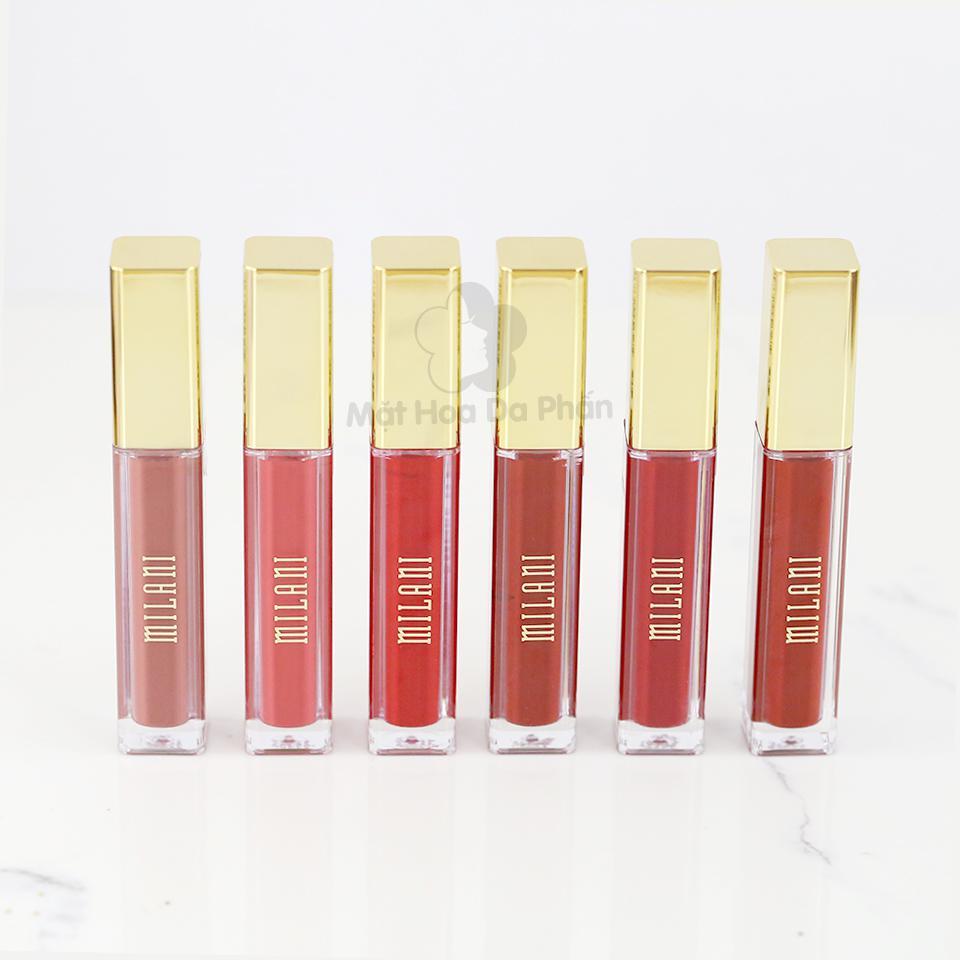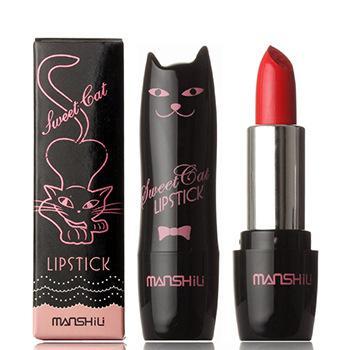The first image is the image on the left, the second image is the image on the right. For the images shown, is this caption "One image contains exactly two colors of lipstick." true? Answer yes or no. No. 